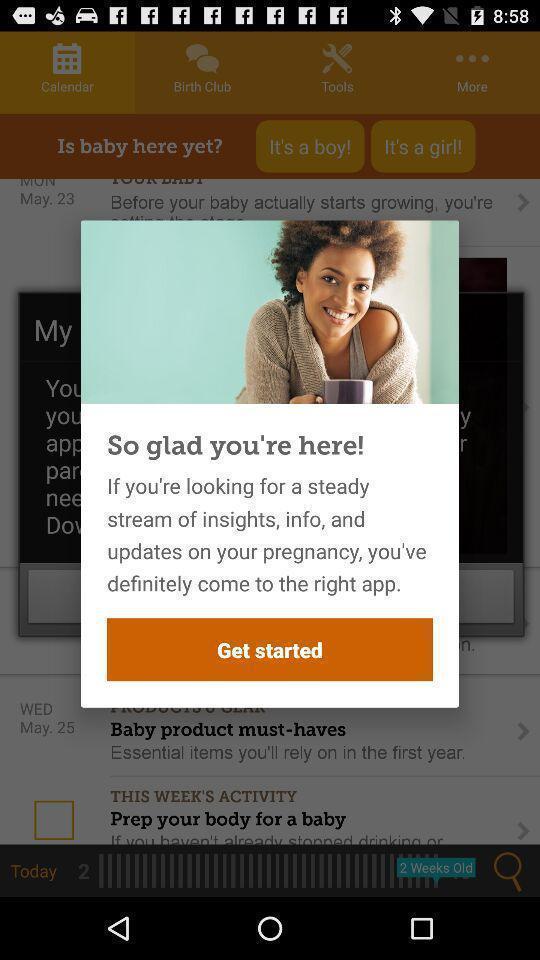Summarize the information in this screenshot. Push up message to get started in a health app. 